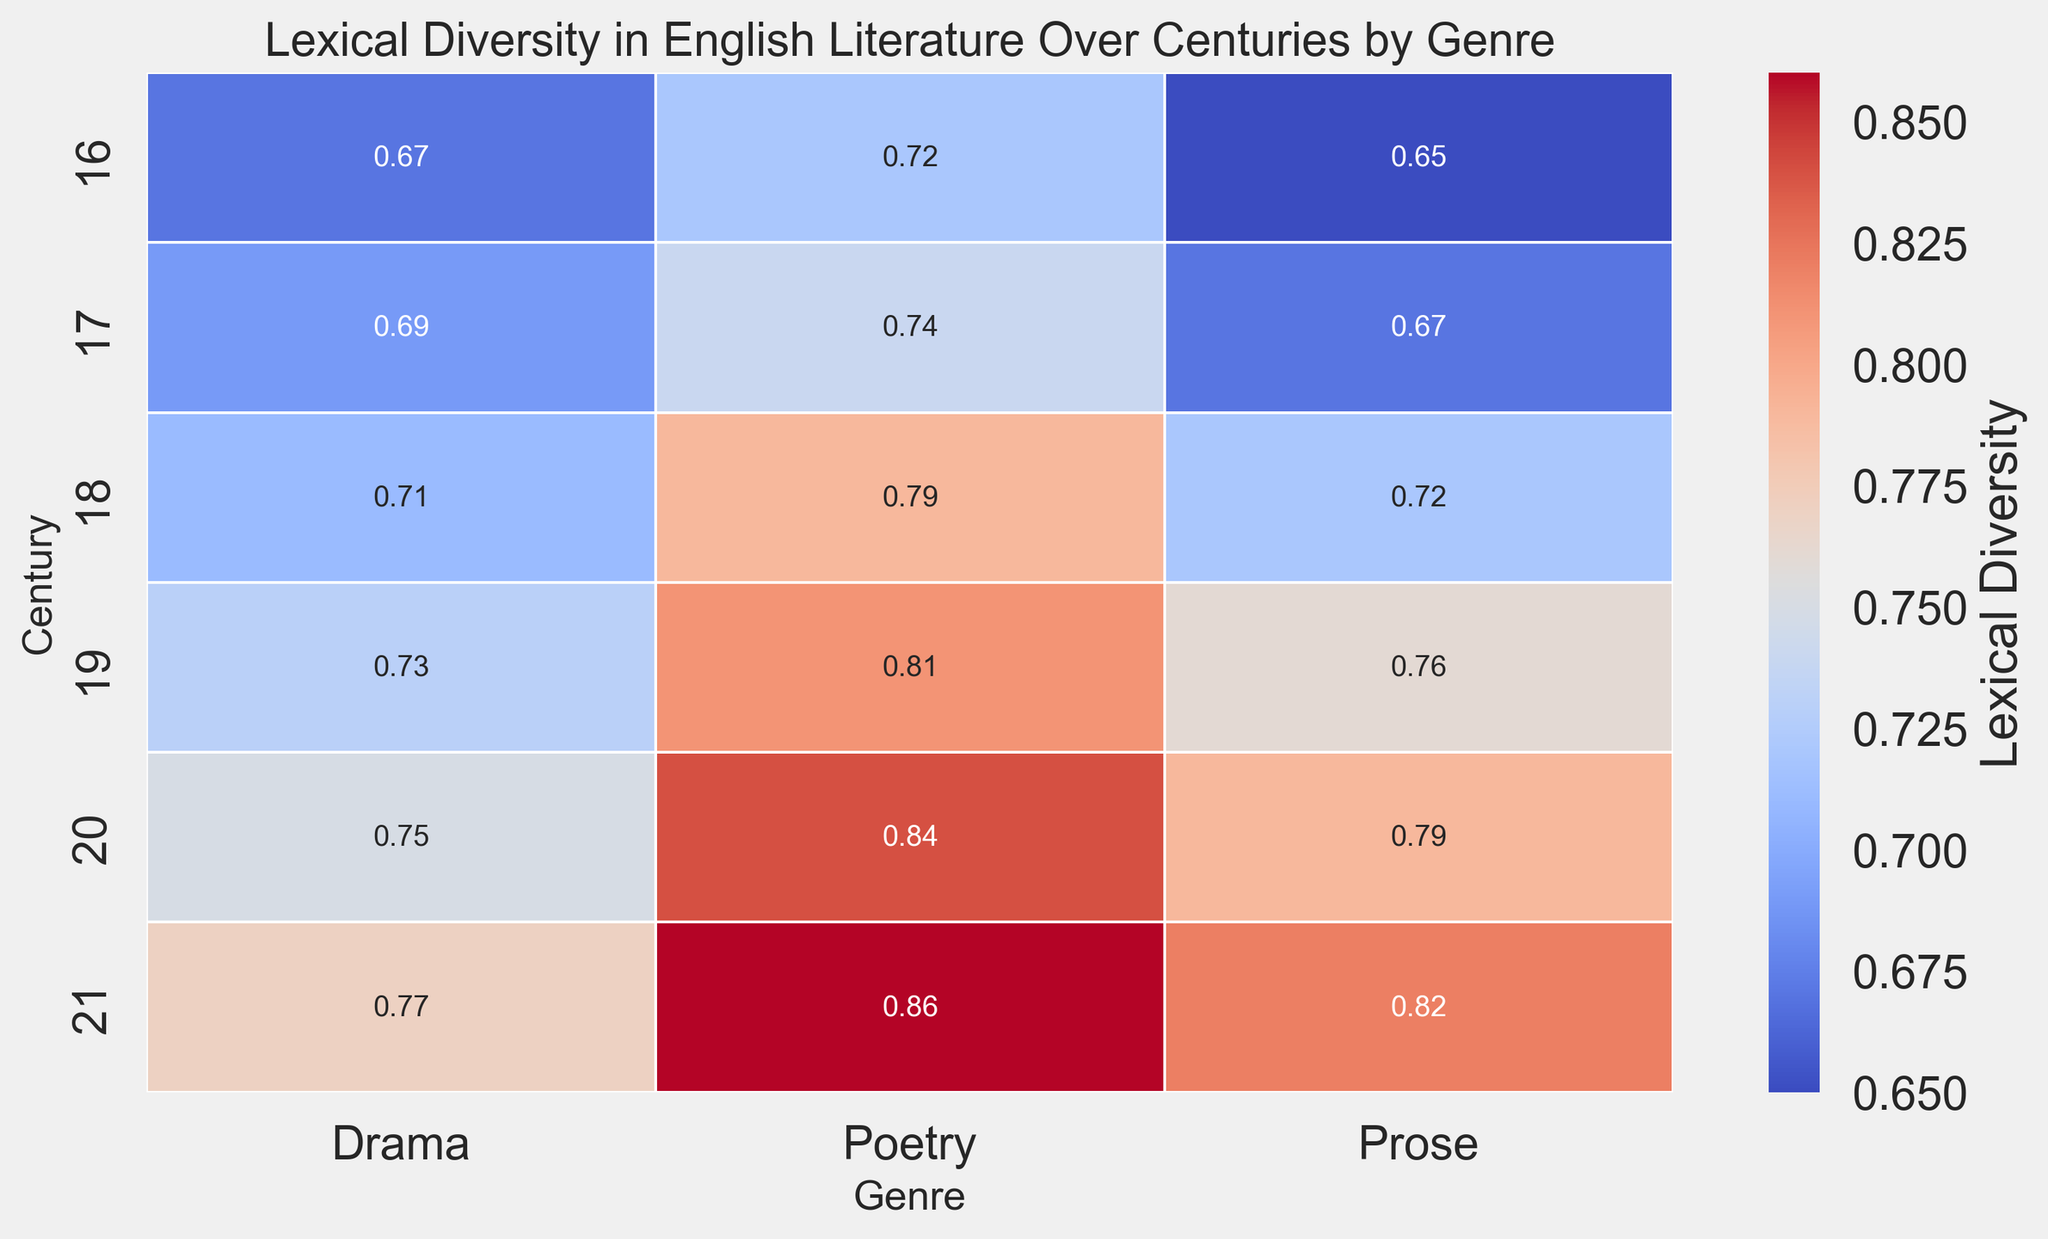Which century has the highest lexical diversity for Poetry? To find out which century has the highest lexical diversity for Poetry, we look down the column marked "Poetry" and identify the highest value. The highest value is 0.86, which belongs to the 21st century.
Answer: 21st century How does the lexical diversity of Drama in the 18th century compare to that in the 16th century? We look at the values in the "Drama" column for both the 16th and 18th centuries. In the 16th century, the value is 0.67, and in the 18th century, the value is 0.71. Since 0.71 is greater than 0.67, lexical diversity for Drama increased from the 16th to the 18th century.
Answer: Increased Which genre shows the most significant increase in lexical diversity from the 16th to the 21st century? We need to calculate the difference between the 21st and the 16th centuries for each genre. For Drama: 0.77 - 0.67 = 0.10. For Poetry: 0.86 - 0.72 = 0.14. For Prose: 0.82 - 0.65 = 0.17. The most significant increase is in Prose.
Answer: Prose What is the average lexical diversity for all genres in the 19th century? We will calculate the average by summing the values for all three genres in the 19th century and then dividing by 3. (0.73 for Drama + 0.81 for Poetry + 0.76 for Prose) / 3 = 2.30 / 3 = 0.77.
Answer: 0.77 Is there a century where all genres have a lexical diversity above 0.70? We need to look at the values for each genre in each century. For the 20th century, Drama is 0.75, Poetry is 0.84, and Prose is 0.79, which are all above 0.70. No other century has all genres above 0.70.
Answer: 20th century Which genre has the most stable lexical diversity across centuries? To determine this, we look for the smallest range (difference between maximum and minimum value) within each genre. For Drama: max 0.77 - min 0.67 = 0.10. For Poetry: max 0.86 - min 0.72 = 0.14. For Prose: max 0.82 - min 0.65 = 0.17. The most stable genre is Drama with a range of 0.10.
Answer: Drama Is the lexical diversity of Poetry consistently higher than that of Drama across centuries? We check the "Poetry" and "Drama" columns for each century. In each comparison (16th: 0.72 vs. 0.67, 17th: 0.74 vs. 0.69, 18th: 0.79 vs. 0.71, 19th: 0.81 vs. 0.73, 20th: 0.84 vs. 0.75, 21st: 0.86 vs. 0.77), Poetry's value is higher than Drama's.
Answer: Yes What is the difference in lexical diversity between Poetry and Prose in the 20th century? The value for Poetry in the 20th century is 0.84, and for Prose, it is 0.79. Subtract the two values: 0.84 - 0.79 = 0.05.
Answer: 0.05 Which century has the lowest overall lexical diversity for all three genres? To find this, we sum the values for all three genres in each century and compare the results. Calculate the sums: 16th (0.67 + 0.72 + 0.65) = 2.04, 17th (0.69 + 0.74 + 0.67) = 2.10, 18th (0.71 + 0.79 + 0.72) = 2.22, 19th (0.73 + 0.81 + 0.76) = 2.30, 20th (0.75 + 0.84 + 0.79) = 2.38, 21st (0.77 + 0.86 + 0.82) = 2.45. The 16th century has the lowest total of 2.04.
Answer: 16th century 